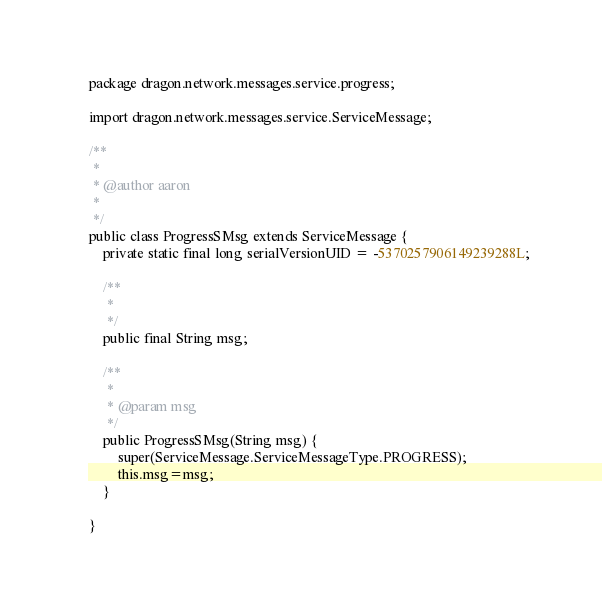<code> <loc_0><loc_0><loc_500><loc_500><_Java_>package dragon.network.messages.service.progress;

import dragon.network.messages.service.ServiceMessage;

/**
 * 
 * @author aaron
 *
 */
public class ProgressSMsg extends ServiceMessage {
	private static final long serialVersionUID = -5370257906149239288L;
	
	/**
	 * 
	 */
	public final String msg;
	
	/**
	 * 
	 * @param msg
	 */
	public ProgressSMsg(String msg) {
		super(ServiceMessage.ServiceMessageType.PROGRESS);
		this.msg=msg;
	}

}
</code> 